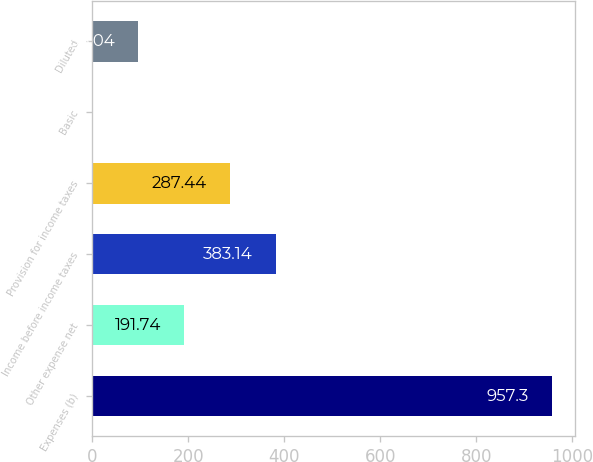Convert chart to OTSL. <chart><loc_0><loc_0><loc_500><loc_500><bar_chart><fcel>Expenses (b)<fcel>Other expense net<fcel>Income before income taxes<fcel>Provision for income taxes<fcel>Basic<fcel>Diluted<nl><fcel>957.3<fcel>191.74<fcel>383.14<fcel>287.44<fcel>0.34<fcel>96.04<nl></chart> 